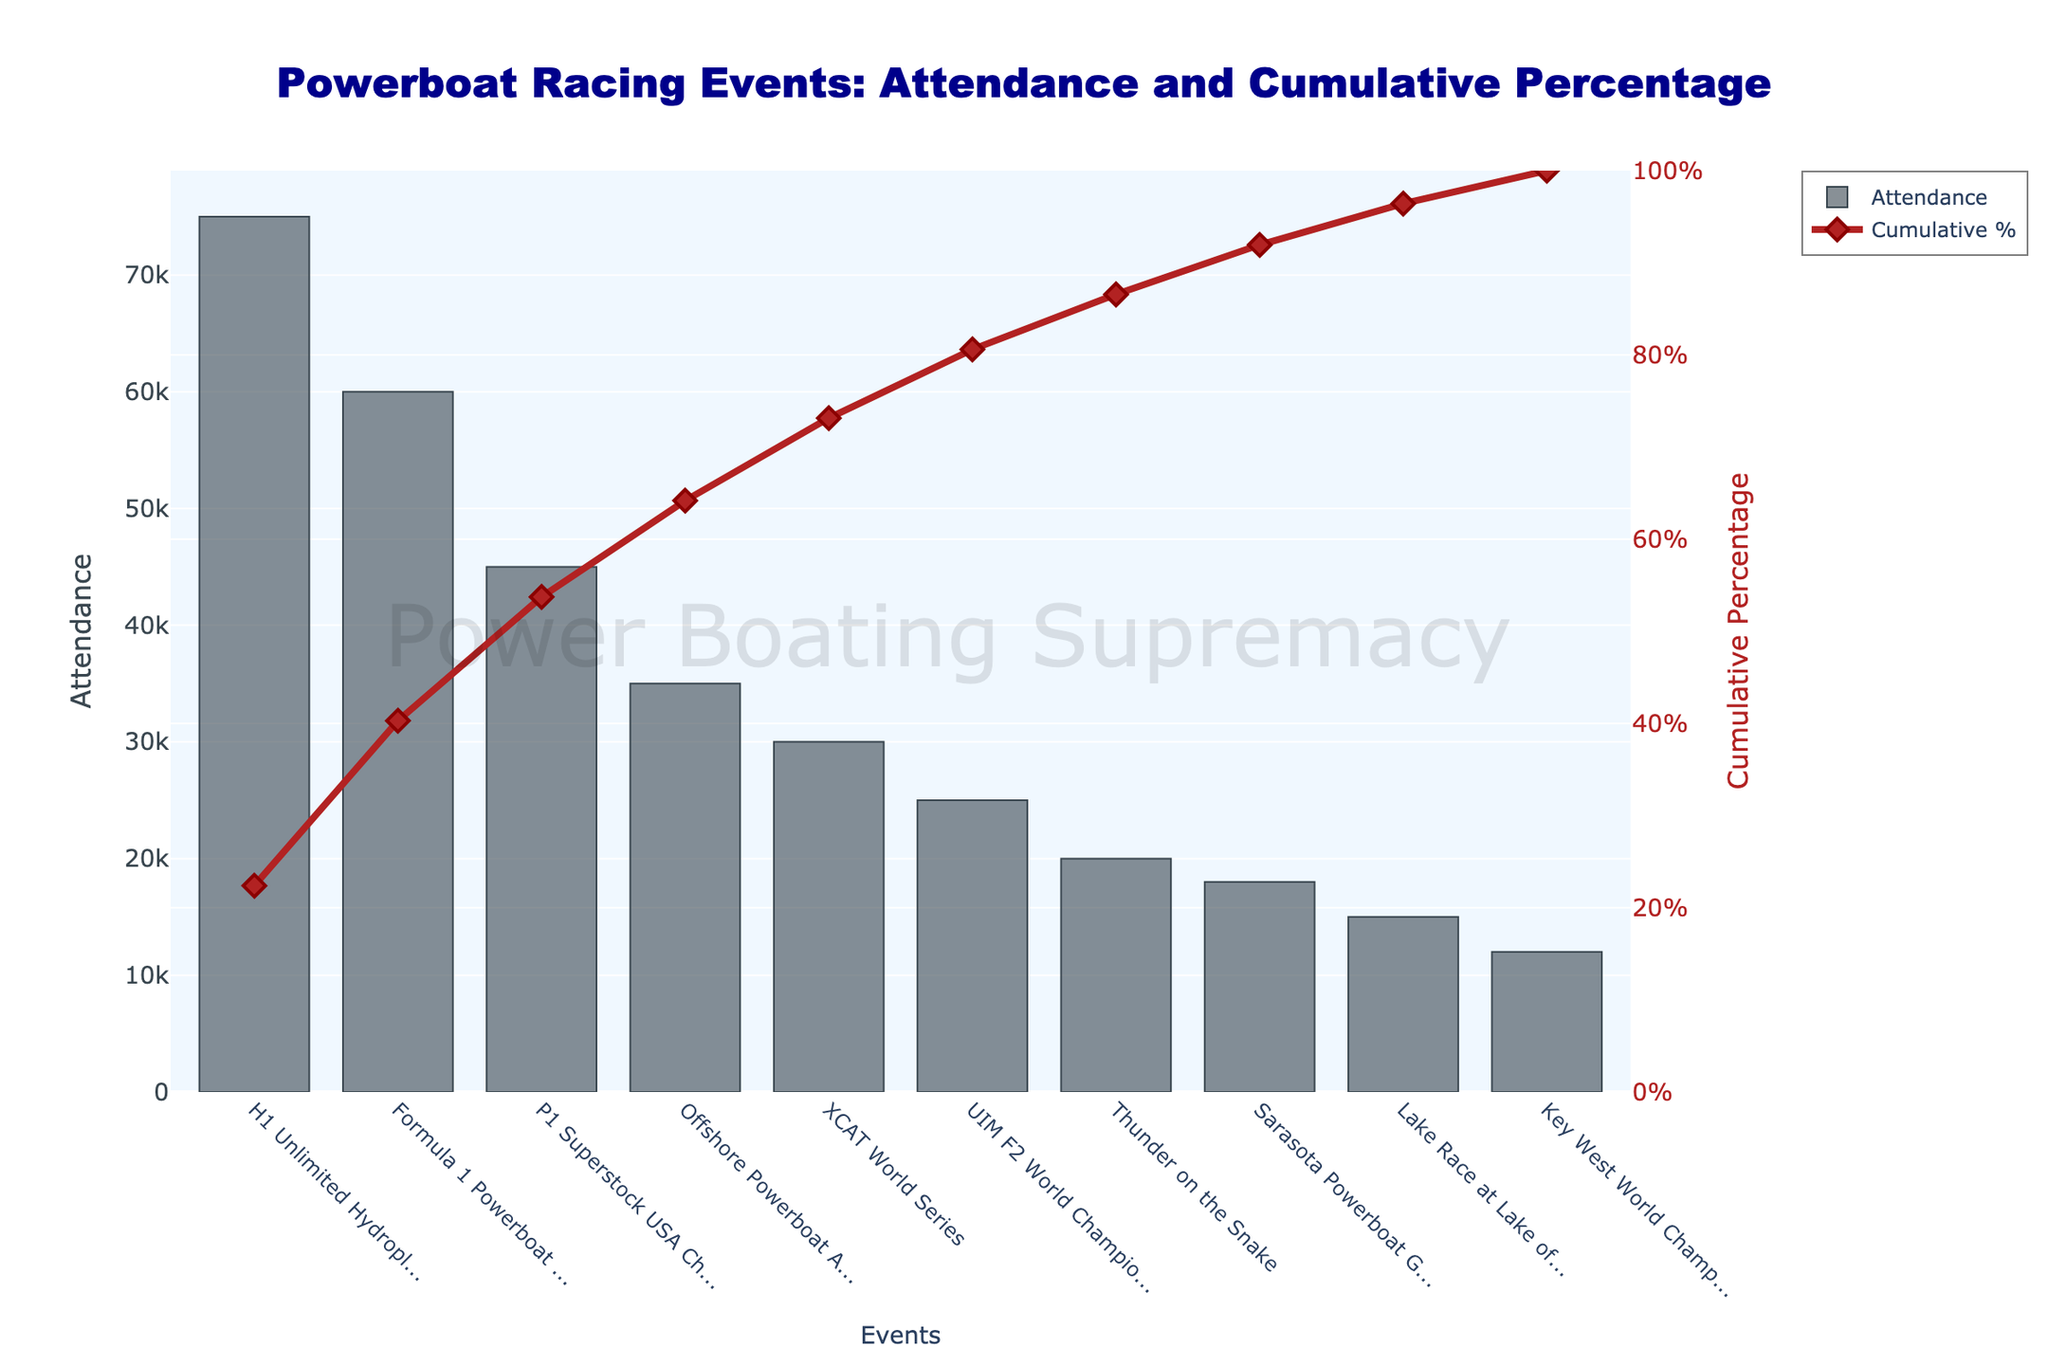What is the event with the highest attendance? The event with the highest attendance can be identified by looking at the tallest bar in the bar chart.
Answer: H1 Unlimited Hydroplane Racing What is the cumulative percentage of attendance by the third event? To find the cumulative percentage by the third event, sum the attendance of the three events with the highest attendance and refer to the cumulative percentage line for the third event.
Answer: 67% Which event has the lowest attendance? The event with the lowest attendance can be identified by looking at the shortest bar in the bar chart.
Answer: Key West World Championship How many events cumulatively make up at least 90% of the total attendance? To answer this, follow the cumulative percentage line chart and count the number of events until the cumulative percentage reaches or exceeds 90%.
Answer: 8 What is the total attendance of the top five attended events? Sum the attendance of the top five events, identified by the five tallest bars. The values are 75000, 60000, 45000, 35000, and 30000.
Answer: 245000 Which event's attendance places it at the 70% cumulative percentage? Find the event at which the cumulative percentage line intersects the 70% mark on the secondary y-axis.
Answer: P1 Superstock USA Championship How does the attendance of the 'Sarasota Powerboat Grand Prix' compare to the 'Lake Race at Lake of the Ozarks'? Compare the height of the bars representing attendance for both events.
Answer: Sarasota Powerboat Grand Prix has a higher attendance by 3000 What is the difference in attendance between the event with the highest and the lowest attendance? Subtract the attendance of the event with the lowest attendance from that of the event with the highest attendance. The values are 75000 and 12000 respectively.
Answer: 63000 What cumulative percentage is reached by the top two events? Sum the attendance of the top two events and calculate their cumulative percentage. The cumulative percentage can also be directly obtained from the dashed line chart for the second event.
Answer: 52% What is the attendance of the event that appears immediately before the cumulative percentage reaches 85%? Look at the event just before the cumulative percentage line intersects the 85% mark on the secondary y-axis.
Answer: Thunder on the Snake - 20000 